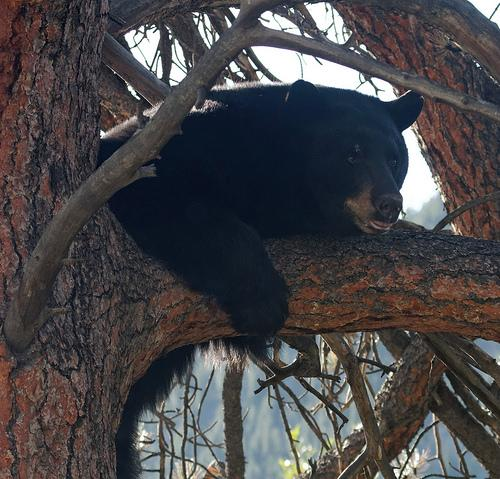Can you identify the primary subject in the picture and describe what this subject is doing? The primary subject is a black bear, and it is climbing a large brown tree and resting on a branch. Please provide a brief description of the central subject involved in the image and mention its primary activity. A black bear is climbing a large brown tree and resting on one of its thick branches. Describe the main focus of the image and what is happening in the scene. The main focus is a black bear who is climbing a tree and pausing to rest on one of its branches. What is the most important object in the image and what is its primary activity? The most important object is a black bear, which is hanging onto a tree and resting on one of its branches. Select the primary object in the image and indicate its central function. The primary object is a black bear which is hanging on a tree branch. Identify the central character in the image and provide a brief description of their action. The central character is a black bear that is currently climbing up a tree and resting on one of its large branches. Mention the core element in the image and what it is engaged in. The core element is a black bear which is climbing up a tree and resting on one of its branches. Please describe the main object in the image and its associated action. The main object is a black bear which is actively climbing a large brown tree and resting on one of its branches. Mention the key subject of the photo and describe what is happening. The key subject is a black bear that is climbing a tree and taking a break on a thick branch. What is the most important feature in the photograph and what is happening in the scene? The most important feature is a black bear that is resting on a thick tree branch and climbing up the tree. 